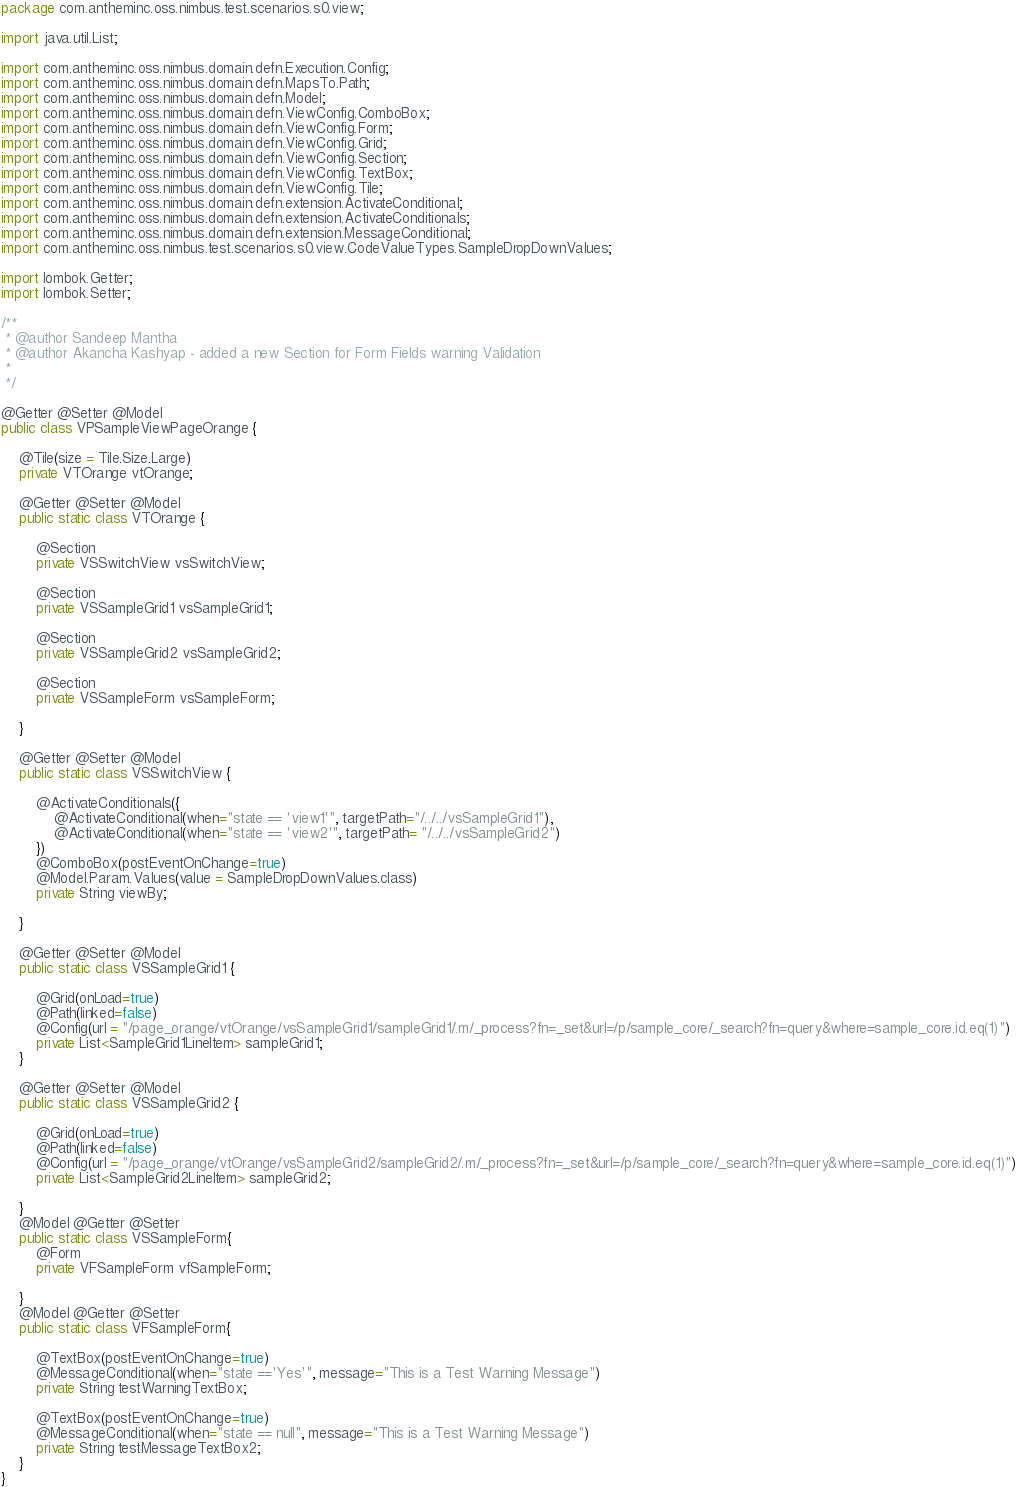<code> <loc_0><loc_0><loc_500><loc_500><_Java_>package com.antheminc.oss.nimbus.test.scenarios.s0.view;

import java.util.List;

import com.antheminc.oss.nimbus.domain.defn.Execution.Config;
import com.antheminc.oss.nimbus.domain.defn.MapsTo.Path;
import com.antheminc.oss.nimbus.domain.defn.Model;
import com.antheminc.oss.nimbus.domain.defn.ViewConfig.ComboBox;
import com.antheminc.oss.nimbus.domain.defn.ViewConfig.Form;
import com.antheminc.oss.nimbus.domain.defn.ViewConfig.Grid;
import com.antheminc.oss.nimbus.domain.defn.ViewConfig.Section;
import com.antheminc.oss.nimbus.domain.defn.ViewConfig.TextBox;
import com.antheminc.oss.nimbus.domain.defn.ViewConfig.Tile;
import com.antheminc.oss.nimbus.domain.defn.extension.ActivateConditional;
import com.antheminc.oss.nimbus.domain.defn.extension.ActivateConditionals;
import com.antheminc.oss.nimbus.domain.defn.extension.MessageConditional;
import com.antheminc.oss.nimbus.test.scenarios.s0.view.CodeValueTypes.SampleDropDownValues;

import lombok.Getter;
import lombok.Setter;

/**
 * @author Sandeep Mantha
 * @author Akancha Kashyap - added a new Section for Form Fields warning Validation
 *
 */

@Getter @Setter @Model
public class VPSampleViewPageOrange {

	@Tile(size = Tile.Size.Large)
	private VTOrange vtOrange;
	
	@Getter @Setter @Model
	public static class VTOrange {
		
		@Section
		private VSSwitchView vsSwitchView;
		
		@Section 
		private VSSampleGrid1 vsSampleGrid1;
		
		@Section
		private VSSampleGrid2 vsSampleGrid2;
		
		@Section
		private VSSampleForm vsSampleForm;
		
	}
	
	@Getter @Setter @Model
	public static class VSSwitchView {
		
		@ActivateConditionals({
			@ActivateConditional(when="state == 'view1'", targetPath="/../../vsSampleGrid1"), 
			@ActivateConditional(when="state == 'view2'", targetPath= "/../../vsSampleGrid2")	
		})
		@ComboBox(postEventOnChange=true)
		@Model.Param.Values(value = SampleDropDownValues.class)
		private String viewBy;
		
	}
	
	@Getter @Setter @Model
	public static class VSSampleGrid1 {
		
		@Grid(onLoad=true)
		@Path(linked=false)
		@Config(url = "/page_orange/vtOrange/vsSampleGrid1/sampleGrid1/.m/_process?fn=_set&url=/p/sample_core/_search?fn=query&where=sample_core.id.eq(1)")
		private List<SampleGrid1LineItem> sampleGrid1;
	}
	
	@Getter @Setter @Model
	public static class VSSampleGrid2 {
		
		@Grid(onLoad=true)
		@Path(linked=false)
		@Config(url = "/page_orange/vtOrange/vsSampleGrid2/sampleGrid2/.m/_process?fn=_set&url=/p/sample_core/_search?fn=query&where=sample_core.id.eq(1)")
		private List<SampleGrid2LineItem> sampleGrid2;
		
	}
	@Model @Getter @Setter
	public static class VSSampleForm{
		@Form
		private VFSampleForm vfSampleForm;
		
	}
	@Model @Getter @Setter
	public static class VFSampleForm{
		
		@TextBox(postEventOnChange=true)
		@MessageConditional(when="state =='Yes'", message="This is a Test Warning Message")
		private String testWarningTextBox;
		
		@TextBox(postEventOnChange=true)
		@MessageConditional(when="state == null", message="This is a Test Warning Message")
		private String testMessageTextBox2;
	}
}</code> 